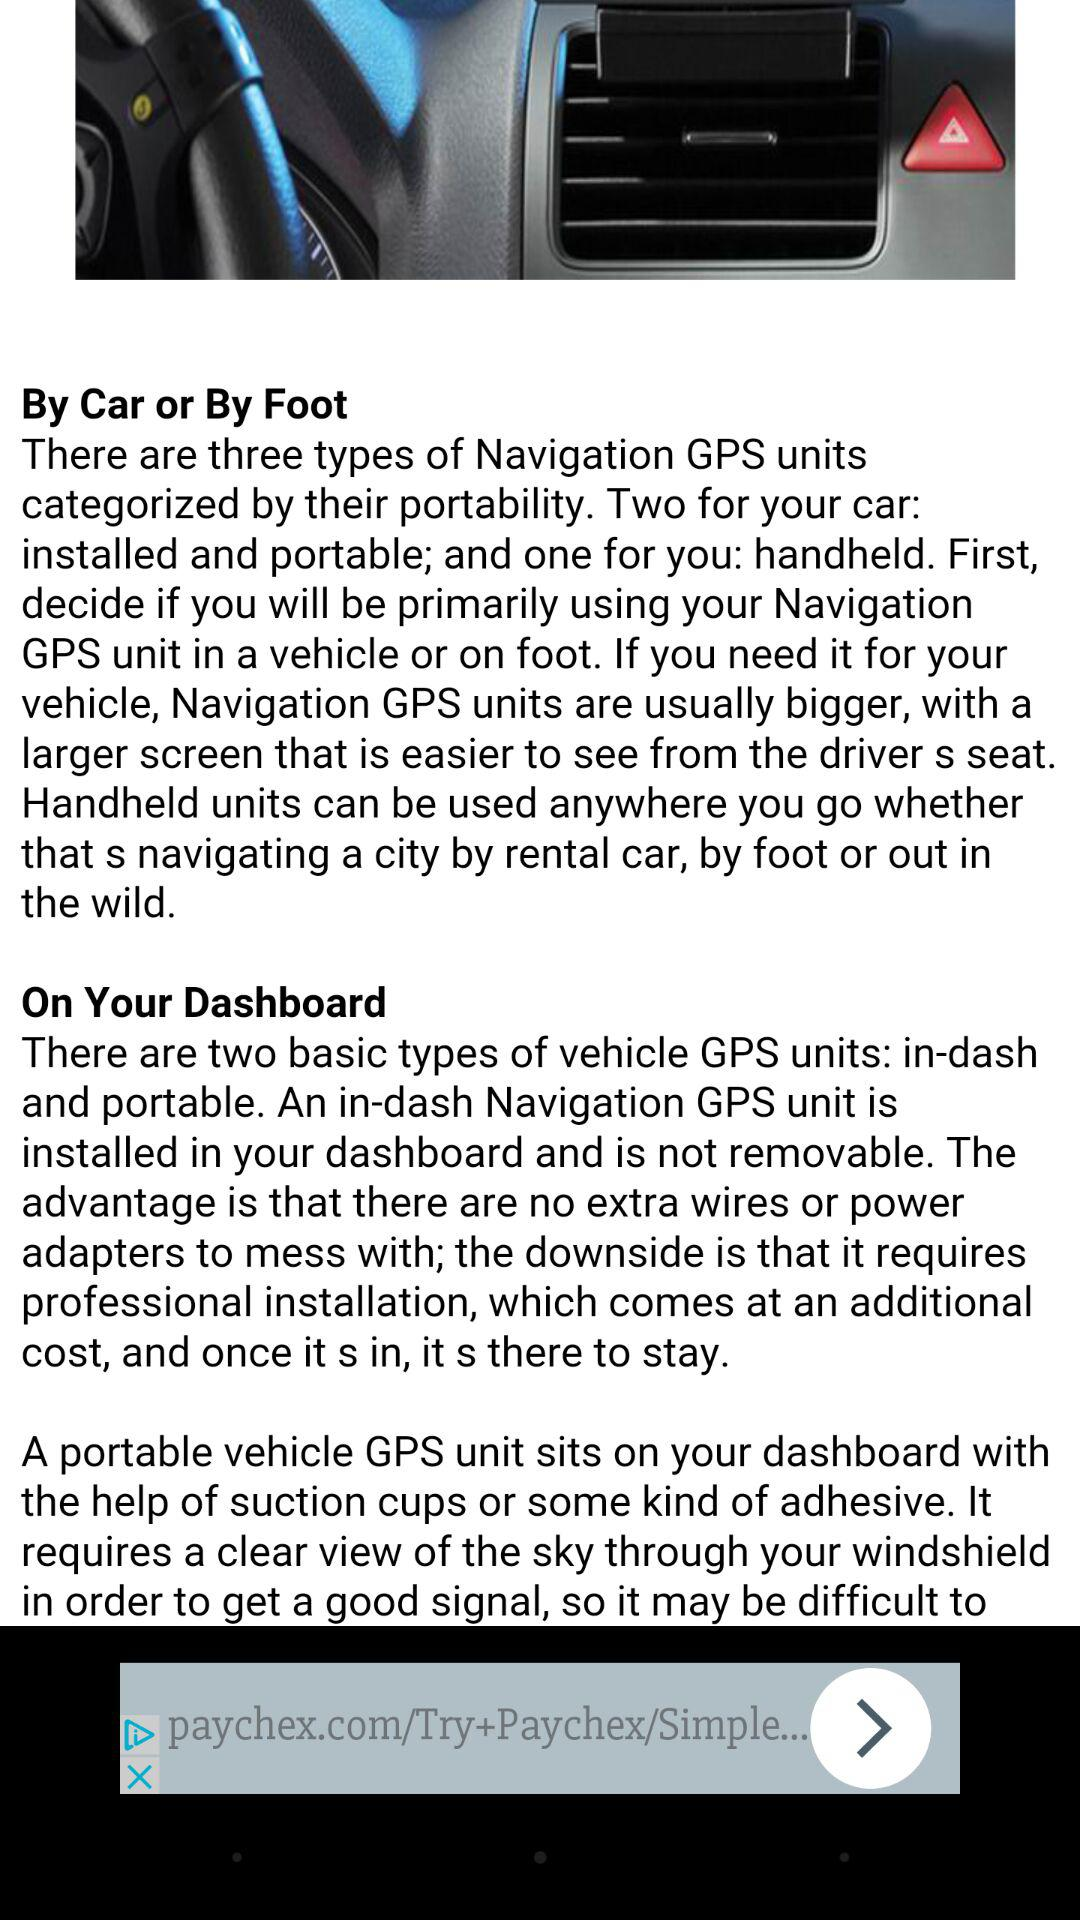How many types of vehicle GPS units are not removable?
Answer the question using a single word or phrase. 1 